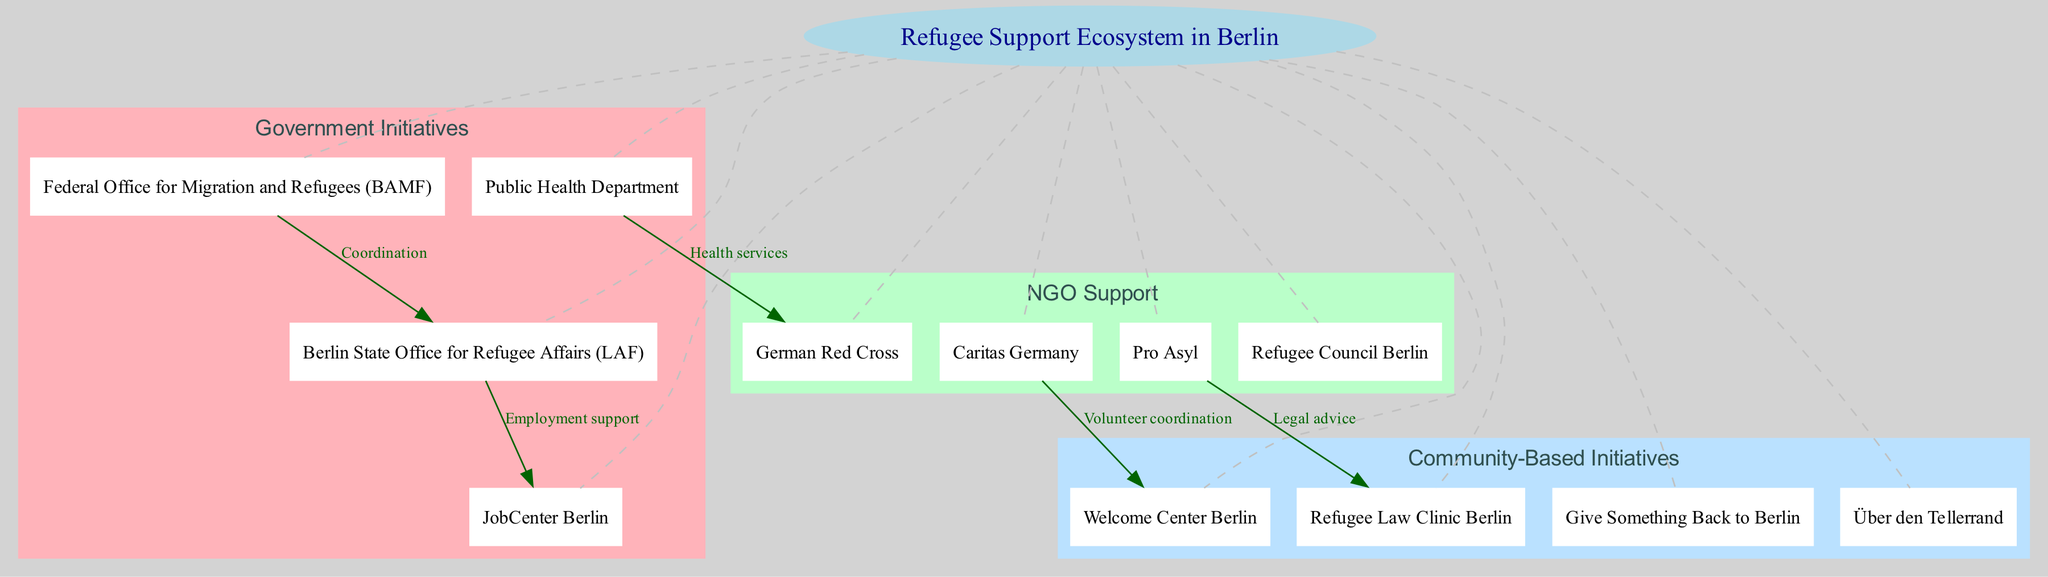What is the central node of the diagram? The central node is explicitly identified in the diagram and represents the overall theme of the ecosystem. The label for the central node is provided directly in the data.
Answer: Refugee Support Ecosystem in Berlin How many layers are present in the diagram? The diagram specifies three distinct layers under "layers" in the data, and each layer corresponds to a category of support services.
Answer: 3 Which NGO is connected to the Welcome Center Berlin? The diagram shows a direct connection from the node "Caritas Germany" to "Welcome Center Berlin." This relationship indicates involvement or support functions of the NGO.
Answer: Caritas Germany What type of support is indicated between the Berlin State Office for Refugee Affairs and JobCenter Berlin? The diagram specifies a connection labeled "Employment support" between these two nodes, which highlights the focus on job placement and related services.
Answer: Employment support Which organization provides health services connected with the Public Health Department? According to the connections in the diagram, the "German Red Cross" is linked with the Public Health Department, which underlines their collaboration in health-related initiatives.
Answer: German Red Cross What is the purpose of the connection between Pro Asyl and Refugee Law Clinic Berlin? In the diagram, this connection is labeled "Legal advice," indicating that Pro Asyl provides legal assistance or related services to the Refugee Law Clinic.
Answer: Legal advice Which layer includes the Refugee Council Berlin? By examining the nodes listed in the layers, we find that "Refugee Council Berlin" is present in the "NGO Support" layer, indicating its role in providing assistance.
Answer: NGO Support What color is used to denote the Government Initiatives layer? Each layer in the diagram is color-coded for easy identification. Referring to the data, the first layer, "Government Initiatives," is color-coded "#FFB3BA."
Answer: #FFB3BA How many direct connections are there in total in the diagram? The diagram's connections section lists five distinct connections, each tying different nodes together, demonstrating the interrelationships within the ecosystem.
Answer: 5 